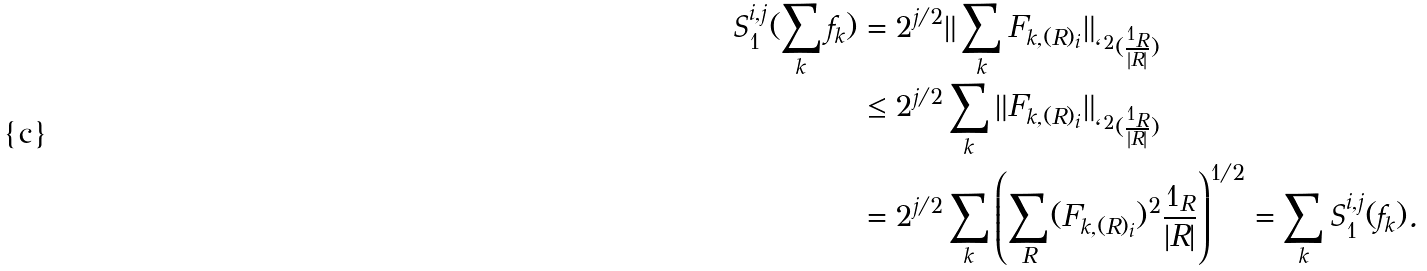Convert formula to latex. <formula><loc_0><loc_0><loc_500><loc_500>S _ { 1 } ^ { i , j } ( \sum _ { k } f _ { k } ) & = 2 ^ { j / 2 } \| \sum _ { k } F _ { k , ( R ) _ { i } } \| _ { \ell ^ { 2 } ( \frac { 1 _ { R } } { | R | } ) } \\ & \leq 2 ^ { j / 2 } \sum _ { k } \| F _ { k , ( R ) _ { i } } \| _ { \ell ^ { 2 } ( \frac { 1 _ { R } } { | R | } ) } \\ & = 2 ^ { j / 2 } \sum _ { k } \left ( \sum _ { R } ( F _ { k , ( R ) _ { i } } ) ^ { 2 } \frac { 1 _ { R } } { | R | } \right ) ^ { 1 / 2 } = \sum _ { k } S _ { 1 } ^ { i , j } ( f _ { k } ) .</formula> 